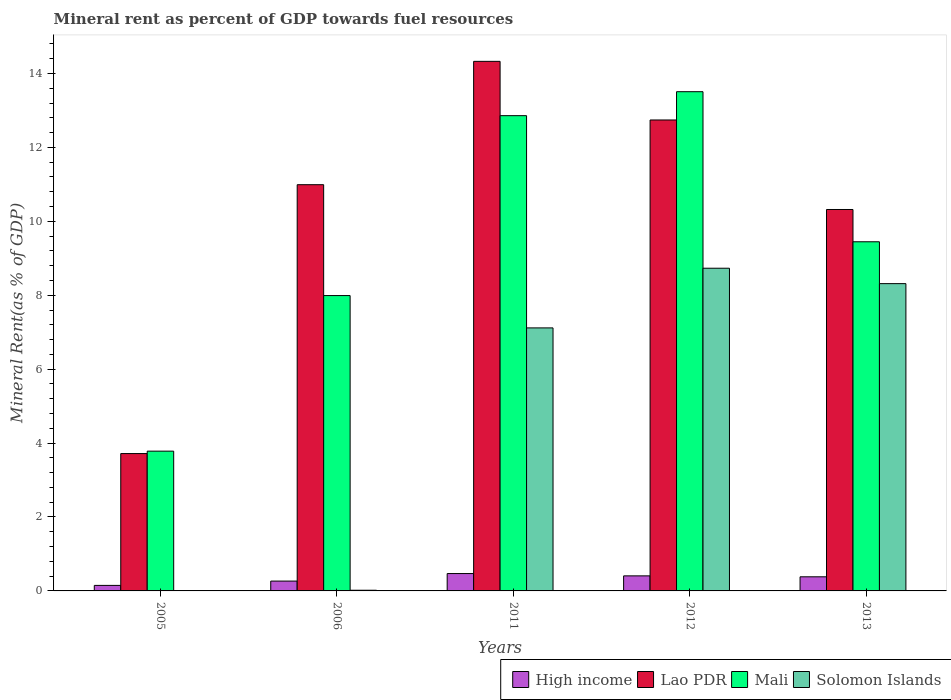Are the number of bars on each tick of the X-axis equal?
Provide a succinct answer. Yes. How many bars are there on the 4th tick from the left?
Keep it short and to the point. 4. How many bars are there on the 1st tick from the right?
Your response must be concise. 4. What is the label of the 4th group of bars from the left?
Offer a very short reply. 2012. In how many cases, is the number of bars for a given year not equal to the number of legend labels?
Provide a short and direct response. 0. What is the mineral rent in Lao PDR in 2013?
Make the answer very short. 10.32. Across all years, what is the maximum mineral rent in Lao PDR?
Your answer should be very brief. 14.33. Across all years, what is the minimum mineral rent in Solomon Islands?
Provide a short and direct response. 0.01. What is the total mineral rent in Mali in the graph?
Your answer should be very brief. 47.58. What is the difference between the mineral rent in High income in 2005 and that in 2013?
Offer a terse response. -0.23. What is the difference between the mineral rent in High income in 2011 and the mineral rent in Mali in 2013?
Keep it short and to the point. -8.98. What is the average mineral rent in Lao PDR per year?
Offer a very short reply. 10.42. In the year 2006, what is the difference between the mineral rent in Lao PDR and mineral rent in Mali?
Provide a short and direct response. 3. What is the ratio of the mineral rent in Mali in 2011 to that in 2012?
Provide a short and direct response. 0.95. What is the difference between the highest and the second highest mineral rent in Solomon Islands?
Your answer should be compact. 0.42. What is the difference between the highest and the lowest mineral rent in Mali?
Offer a terse response. 9.73. In how many years, is the mineral rent in Solomon Islands greater than the average mineral rent in Solomon Islands taken over all years?
Keep it short and to the point. 3. Is it the case that in every year, the sum of the mineral rent in Lao PDR and mineral rent in High income is greater than the sum of mineral rent in Solomon Islands and mineral rent in Mali?
Provide a short and direct response. No. What does the 2nd bar from the right in 2013 represents?
Ensure brevity in your answer.  Mali. Are all the bars in the graph horizontal?
Offer a terse response. No. How many years are there in the graph?
Provide a short and direct response. 5. What is the difference between two consecutive major ticks on the Y-axis?
Provide a succinct answer. 2. Are the values on the major ticks of Y-axis written in scientific E-notation?
Your answer should be very brief. No. Does the graph contain any zero values?
Provide a short and direct response. No. Where does the legend appear in the graph?
Provide a succinct answer. Bottom right. What is the title of the graph?
Offer a very short reply. Mineral rent as percent of GDP towards fuel resources. What is the label or title of the Y-axis?
Keep it short and to the point. Mineral Rent(as % of GDP). What is the Mineral Rent(as % of GDP) of High income in 2005?
Make the answer very short. 0.15. What is the Mineral Rent(as % of GDP) in Lao PDR in 2005?
Ensure brevity in your answer.  3.72. What is the Mineral Rent(as % of GDP) of Mali in 2005?
Offer a very short reply. 3.78. What is the Mineral Rent(as % of GDP) of Solomon Islands in 2005?
Give a very brief answer. 0.01. What is the Mineral Rent(as % of GDP) of High income in 2006?
Give a very brief answer. 0.27. What is the Mineral Rent(as % of GDP) of Lao PDR in 2006?
Your answer should be very brief. 10.99. What is the Mineral Rent(as % of GDP) of Mali in 2006?
Your answer should be compact. 7.99. What is the Mineral Rent(as % of GDP) of Solomon Islands in 2006?
Provide a short and direct response. 0.02. What is the Mineral Rent(as % of GDP) of High income in 2011?
Make the answer very short. 0.47. What is the Mineral Rent(as % of GDP) of Lao PDR in 2011?
Make the answer very short. 14.33. What is the Mineral Rent(as % of GDP) of Mali in 2011?
Provide a short and direct response. 12.86. What is the Mineral Rent(as % of GDP) in Solomon Islands in 2011?
Provide a succinct answer. 7.12. What is the Mineral Rent(as % of GDP) of High income in 2012?
Offer a very short reply. 0.41. What is the Mineral Rent(as % of GDP) in Lao PDR in 2012?
Keep it short and to the point. 12.74. What is the Mineral Rent(as % of GDP) of Mali in 2012?
Offer a very short reply. 13.51. What is the Mineral Rent(as % of GDP) of Solomon Islands in 2012?
Your answer should be compact. 8.73. What is the Mineral Rent(as % of GDP) of High income in 2013?
Offer a terse response. 0.38. What is the Mineral Rent(as % of GDP) of Lao PDR in 2013?
Keep it short and to the point. 10.32. What is the Mineral Rent(as % of GDP) in Mali in 2013?
Give a very brief answer. 9.45. What is the Mineral Rent(as % of GDP) in Solomon Islands in 2013?
Offer a terse response. 8.31. Across all years, what is the maximum Mineral Rent(as % of GDP) in High income?
Make the answer very short. 0.47. Across all years, what is the maximum Mineral Rent(as % of GDP) in Lao PDR?
Offer a very short reply. 14.33. Across all years, what is the maximum Mineral Rent(as % of GDP) in Mali?
Provide a short and direct response. 13.51. Across all years, what is the maximum Mineral Rent(as % of GDP) of Solomon Islands?
Provide a short and direct response. 8.73. Across all years, what is the minimum Mineral Rent(as % of GDP) of High income?
Your response must be concise. 0.15. Across all years, what is the minimum Mineral Rent(as % of GDP) of Lao PDR?
Your answer should be compact. 3.72. Across all years, what is the minimum Mineral Rent(as % of GDP) of Mali?
Keep it short and to the point. 3.78. Across all years, what is the minimum Mineral Rent(as % of GDP) in Solomon Islands?
Keep it short and to the point. 0.01. What is the total Mineral Rent(as % of GDP) in High income in the graph?
Your response must be concise. 1.67. What is the total Mineral Rent(as % of GDP) in Lao PDR in the graph?
Your answer should be compact. 52.1. What is the total Mineral Rent(as % of GDP) of Mali in the graph?
Give a very brief answer. 47.58. What is the total Mineral Rent(as % of GDP) of Solomon Islands in the graph?
Give a very brief answer. 24.19. What is the difference between the Mineral Rent(as % of GDP) of High income in 2005 and that in 2006?
Your answer should be compact. -0.12. What is the difference between the Mineral Rent(as % of GDP) of Lao PDR in 2005 and that in 2006?
Your answer should be compact. -7.27. What is the difference between the Mineral Rent(as % of GDP) of Mali in 2005 and that in 2006?
Provide a short and direct response. -4.21. What is the difference between the Mineral Rent(as % of GDP) of Solomon Islands in 2005 and that in 2006?
Your answer should be very brief. -0.01. What is the difference between the Mineral Rent(as % of GDP) of High income in 2005 and that in 2011?
Give a very brief answer. -0.32. What is the difference between the Mineral Rent(as % of GDP) of Lao PDR in 2005 and that in 2011?
Offer a terse response. -10.61. What is the difference between the Mineral Rent(as % of GDP) in Mali in 2005 and that in 2011?
Offer a very short reply. -9.08. What is the difference between the Mineral Rent(as % of GDP) in Solomon Islands in 2005 and that in 2011?
Your answer should be compact. -7.11. What is the difference between the Mineral Rent(as % of GDP) in High income in 2005 and that in 2012?
Make the answer very short. -0.26. What is the difference between the Mineral Rent(as % of GDP) in Lao PDR in 2005 and that in 2012?
Give a very brief answer. -9.03. What is the difference between the Mineral Rent(as % of GDP) of Mali in 2005 and that in 2012?
Your answer should be compact. -9.73. What is the difference between the Mineral Rent(as % of GDP) in Solomon Islands in 2005 and that in 2012?
Provide a succinct answer. -8.72. What is the difference between the Mineral Rent(as % of GDP) in High income in 2005 and that in 2013?
Provide a succinct answer. -0.23. What is the difference between the Mineral Rent(as % of GDP) of Lao PDR in 2005 and that in 2013?
Offer a terse response. -6.6. What is the difference between the Mineral Rent(as % of GDP) in Mali in 2005 and that in 2013?
Ensure brevity in your answer.  -5.66. What is the difference between the Mineral Rent(as % of GDP) in Solomon Islands in 2005 and that in 2013?
Your answer should be compact. -8.31. What is the difference between the Mineral Rent(as % of GDP) in High income in 2006 and that in 2011?
Your response must be concise. -0.2. What is the difference between the Mineral Rent(as % of GDP) of Lao PDR in 2006 and that in 2011?
Your answer should be compact. -3.34. What is the difference between the Mineral Rent(as % of GDP) in Mali in 2006 and that in 2011?
Keep it short and to the point. -4.87. What is the difference between the Mineral Rent(as % of GDP) of Solomon Islands in 2006 and that in 2011?
Keep it short and to the point. -7.1. What is the difference between the Mineral Rent(as % of GDP) in High income in 2006 and that in 2012?
Your response must be concise. -0.14. What is the difference between the Mineral Rent(as % of GDP) of Lao PDR in 2006 and that in 2012?
Your answer should be compact. -1.75. What is the difference between the Mineral Rent(as % of GDP) in Mali in 2006 and that in 2012?
Ensure brevity in your answer.  -5.52. What is the difference between the Mineral Rent(as % of GDP) in Solomon Islands in 2006 and that in 2012?
Offer a terse response. -8.71. What is the difference between the Mineral Rent(as % of GDP) of High income in 2006 and that in 2013?
Keep it short and to the point. -0.12. What is the difference between the Mineral Rent(as % of GDP) of Lao PDR in 2006 and that in 2013?
Keep it short and to the point. 0.67. What is the difference between the Mineral Rent(as % of GDP) of Mali in 2006 and that in 2013?
Your answer should be compact. -1.46. What is the difference between the Mineral Rent(as % of GDP) in Solomon Islands in 2006 and that in 2013?
Provide a succinct answer. -8.3. What is the difference between the Mineral Rent(as % of GDP) of High income in 2011 and that in 2012?
Keep it short and to the point. 0.06. What is the difference between the Mineral Rent(as % of GDP) in Lao PDR in 2011 and that in 2012?
Keep it short and to the point. 1.59. What is the difference between the Mineral Rent(as % of GDP) of Mali in 2011 and that in 2012?
Make the answer very short. -0.65. What is the difference between the Mineral Rent(as % of GDP) in Solomon Islands in 2011 and that in 2012?
Keep it short and to the point. -1.61. What is the difference between the Mineral Rent(as % of GDP) of High income in 2011 and that in 2013?
Give a very brief answer. 0.09. What is the difference between the Mineral Rent(as % of GDP) in Lao PDR in 2011 and that in 2013?
Offer a very short reply. 4.01. What is the difference between the Mineral Rent(as % of GDP) of Mali in 2011 and that in 2013?
Ensure brevity in your answer.  3.41. What is the difference between the Mineral Rent(as % of GDP) in Solomon Islands in 2011 and that in 2013?
Your answer should be compact. -1.2. What is the difference between the Mineral Rent(as % of GDP) in High income in 2012 and that in 2013?
Provide a short and direct response. 0.03. What is the difference between the Mineral Rent(as % of GDP) of Lao PDR in 2012 and that in 2013?
Keep it short and to the point. 2.42. What is the difference between the Mineral Rent(as % of GDP) of Mali in 2012 and that in 2013?
Provide a short and direct response. 4.06. What is the difference between the Mineral Rent(as % of GDP) in Solomon Islands in 2012 and that in 2013?
Provide a short and direct response. 0.42. What is the difference between the Mineral Rent(as % of GDP) in High income in 2005 and the Mineral Rent(as % of GDP) in Lao PDR in 2006?
Give a very brief answer. -10.84. What is the difference between the Mineral Rent(as % of GDP) in High income in 2005 and the Mineral Rent(as % of GDP) in Mali in 2006?
Provide a short and direct response. -7.84. What is the difference between the Mineral Rent(as % of GDP) of High income in 2005 and the Mineral Rent(as % of GDP) of Solomon Islands in 2006?
Your response must be concise. 0.13. What is the difference between the Mineral Rent(as % of GDP) in Lao PDR in 2005 and the Mineral Rent(as % of GDP) in Mali in 2006?
Make the answer very short. -4.27. What is the difference between the Mineral Rent(as % of GDP) of Lao PDR in 2005 and the Mineral Rent(as % of GDP) of Solomon Islands in 2006?
Your answer should be compact. 3.7. What is the difference between the Mineral Rent(as % of GDP) of Mali in 2005 and the Mineral Rent(as % of GDP) of Solomon Islands in 2006?
Offer a very short reply. 3.76. What is the difference between the Mineral Rent(as % of GDP) in High income in 2005 and the Mineral Rent(as % of GDP) in Lao PDR in 2011?
Your answer should be very brief. -14.18. What is the difference between the Mineral Rent(as % of GDP) in High income in 2005 and the Mineral Rent(as % of GDP) in Mali in 2011?
Your answer should be compact. -12.71. What is the difference between the Mineral Rent(as % of GDP) in High income in 2005 and the Mineral Rent(as % of GDP) in Solomon Islands in 2011?
Offer a very short reply. -6.97. What is the difference between the Mineral Rent(as % of GDP) of Lao PDR in 2005 and the Mineral Rent(as % of GDP) of Mali in 2011?
Make the answer very short. -9.14. What is the difference between the Mineral Rent(as % of GDP) in Lao PDR in 2005 and the Mineral Rent(as % of GDP) in Solomon Islands in 2011?
Provide a succinct answer. -3.4. What is the difference between the Mineral Rent(as % of GDP) of Mali in 2005 and the Mineral Rent(as % of GDP) of Solomon Islands in 2011?
Your answer should be compact. -3.33. What is the difference between the Mineral Rent(as % of GDP) in High income in 2005 and the Mineral Rent(as % of GDP) in Lao PDR in 2012?
Offer a very short reply. -12.59. What is the difference between the Mineral Rent(as % of GDP) of High income in 2005 and the Mineral Rent(as % of GDP) of Mali in 2012?
Your answer should be compact. -13.36. What is the difference between the Mineral Rent(as % of GDP) of High income in 2005 and the Mineral Rent(as % of GDP) of Solomon Islands in 2012?
Make the answer very short. -8.58. What is the difference between the Mineral Rent(as % of GDP) in Lao PDR in 2005 and the Mineral Rent(as % of GDP) in Mali in 2012?
Offer a terse response. -9.79. What is the difference between the Mineral Rent(as % of GDP) in Lao PDR in 2005 and the Mineral Rent(as % of GDP) in Solomon Islands in 2012?
Keep it short and to the point. -5.01. What is the difference between the Mineral Rent(as % of GDP) of Mali in 2005 and the Mineral Rent(as % of GDP) of Solomon Islands in 2012?
Ensure brevity in your answer.  -4.95. What is the difference between the Mineral Rent(as % of GDP) of High income in 2005 and the Mineral Rent(as % of GDP) of Lao PDR in 2013?
Your answer should be compact. -10.17. What is the difference between the Mineral Rent(as % of GDP) in High income in 2005 and the Mineral Rent(as % of GDP) in Mali in 2013?
Make the answer very short. -9.3. What is the difference between the Mineral Rent(as % of GDP) in High income in 2005 and the Mineral Rent(as % of GDP) in Solomon Islands in 2013?
Your answer should be compact. -8.16. What is the difference between the Mineral Rent(as % of GDP) in Lao PDR in 2005 and the Mineral Rent(as % of GDP) in Mali in 2013?
Provide a succinct answer. -5.73. What is the difference between the Mineral Rent(as % of GDP) of Lao PDR in 2005 and the Mineral Rent(as % of GDP) of Solomon Islands in 2013?
Provide a short and direct response. -4.6. What is the difference between the Mineral Rent(as % of GDP) of Mali in 2005 and the Mineral Rent(as % of GDP) of Solomon Islands in 2013?
Your answer should be compact. -4.53. What is the difference between the Mineral Rent(as % of GDP) of High income in 2006 and the Mineral Rent(as % of GDP) of Lao PDR in 2011?
Keep it short and to the point. -14.06. What is the difference between the Mineral Rent(as % of GDP) of High income in 2006 and the Mineral Rent(as % of GDP) of Mali in 2011?
Your answer should be compact. -12.59. What is the difference between the Mineral Rent(as % of GDP) of High income in 2006 and the Mineral Rent(as % of GDP) of Solomon Islands in 2011?
Ensure brevity in your answer.  -6.85. What is the difference between the Mineral Rent(as % of GDP) in Lao PDR in 2006 and the Mineral Rent(as % of GDP) in Mali in 2011?
Keep it short and to the point. -1.87. What is the difference between the Mineral Rent(as % of GDP) in Lao PDR in 2006 and the Mineral Rent(as % of GDP) in Solomon Islands in 2011?
Ensure brevity in your answer.  3.87. What is the difference between the Mineral Rent(as % of GDP) in Mali in 2006 and the Mineral Rent(as % of GDP) in Solomon Islands in 2011?
Make the answer very short. 0.87. What is the difference between the Mineral Rent(as % of GDP) in High income in 2006 and the Mineral Rent(as % of GDP) in Lao PDR in 2012?
Give a very brief answer. -12.48. What is the difference between the Mineral Rent(as % of GDP) in High income in 2006 and the Mineral Rent(as % of GDP) in Mali in 2012?
Offer a very short reply. -13.24. What is the difference between the Mineral Rent(as % of GDP) of High income in 2006 and the Mineral Rent(as % of GDP) of Solomon Islands in 2012?
Offer a very short reply. -8.46. What is the difference between the Mineral Rent(as % of GDP) in Lao PDR in 2006 and the Mineral Rent(as % of GDP) in Mali in 2012?
Make the answer very short. -2.52. What is the difference between the Mineral Rent(as % of GDP) in Lao PDR in 2006 and the Mineral Rent(as % of GDP) in Solomon Islands in 2012?
Your answer should be very brief. 2.26. What is the difference between the Mineral Rent(as % of GDP) of Mali in 2006 and the Mineral Rent(as % of GDP) of Solomon Islands in 2012?
Offer a terse response. -0.74. What is the difference between the Mineral Rent(as % of GDP) in High income in 2006 and the Mineral Rent(as % of GDP) in Lao PDR in 2013?
Provide a short and direct response. -10.05. What is the difference between the Mineral Rent(as % of GDP) in High income in 2006 and the Mineral Rent(as % of GDP) in Mali in 2013?
Your answer should be very brief. -9.18. What is the difference between the Mineral Rent(as % of GDP) in High income in 2006 and the Mineral Rent(as % of GDP) in Solomon Islands in 2013?
Provide a succinct answer. -8.05. What is the difference between the Mineral Rent(as % of GDP) in Lao PDR in 2006 and the Mineral Rent(as % of GDP) in Mali in 2013?
Provide a succinct answer. 1.54. What is the difference between the Mineral Rent(as % of GDP) in Lao PDR in 2006 and the Mineral Rent(as % of GDP) in Solomon Islands in 2013?
Give a very brief answer. 2.68. What is the difference between the Mineral Rent(as % of GDP) in Mali in 2006 and the Mineral Rent(as % of GDP) in Solomon Islands in 2013?
Your answer should be very brief. -0.32. What is the difference between the Mineral Rent(as % of GDP) of High income in 2011 and the Mineral Rent(as % of GDP) of Lao PDR in 2012?
Offer a terse response. -12.27. What is the difference between the Mineral Rent(as % of GDP) in High income in 2011 and the Mineral Rent(as % of GDP) in Mali in 2012?
Ensure brevity in your answer.  -13.04. What is the difference between the Mineral Rent(as % of GDP) in High income in 2011 and the Mineral Rent(as % of GDP) in Solomon Islands in 2012?
Provide a succinct answer. -8.26. What is the difference between the Mineral Rent(as % of GDP) of Lao PDR in 2011 and the Mineral Rent(as % of GDP) of Mali in 2012?
Your answer should be compact. 0.82. What is the difference between the Mineral Rent(as % of GDP) of Lao PDR in 2011 and the Mineral Rent(as % of GDP) of Solomon Islands in 2012?
Make the answer very short. 5.6. What is the difference between the Mineral Rent(as % of GDP) of Mali in 2011 and the Mineral Rent(as % of GDP) of Solomon Islands in 2012?
Make the answer very short. 4.13. What is the difference between the Mineral Rent(as % of GDP) of High income in 2011 and the Mineral Rent(as % of GDP) of Lao PDR in 2013?
Give a very brief answer. -9.85. What is the difference between the Mineral Rent(as % of GDP) of High income in 2011 and the Mineral Rent(as % of GDP) of Mali in 2013?
Provide a short and direct response. -8.98. What is the difference between the Mineral Rent(as % of GDP) in High income in 2011 and the Mineral Rent(as % of GDP) in Solomon Islands in 2013?
Provide a succinct answer. -7.84. What is the difference between the Mineral Rent(as % of GDP) in Lao PDR in 2011 and the Mineral Rent(as % of GDP) in Mali in 2013?
Your answer should be very brief. 4.88. What is the difference between the Mineral Rent(as % of GDP) of Lao PDR in 2011 and the Mineral Rent(as % of GDP) of Solomon Islands in 2013?
Ensure brevity in your answer.  6.01. What is the difference between the Mineral Rent(as % of GDP) in Mali in 2011 and the Mineral Rent(as % of GDP) in Solomon Islands in 2013?
Offer a very short reply. 4.54. What is the difference between the Mineral Rent(as % of GDP) in High income in 2012 and the Mineral Rent(as % of GDP) in Lao PDR in 2013?
Your response must be concise. -9.91. What is the difference between the Mineral Rent(as % of GDP) in High income in 2012 and the Mineral Rent(as % of GDP) in Mali in 2013?
Provide a short and direct response. -9.04. What is the difference between the Mineral Rent(as % of GDP) in High income in 2012 and the Mineral Rent(as % of GDP) in Solomon Islands in 2013?
Your response must be concise. -7.91. What is the difference between the Mineral Rent(as % of GDP) in Lao PDR in 2012 and the Mineral Rent(as % of GDP) in Mali in 2013?
Your response must be concise. 3.3. What is the difference between the Mineral Rent(as % of GDP) of Lao PDR in 2012 and the Mineral Rent(as % of GDP) of Solomon Islands in 2013?
Give a very brief answer. 4.43. What is the difference between the Mineral Rent(as % of GDP) of Mali in 2012 and the Mineral Rent(as % of GDP) of Solomon Islands in 2013?
Your answer should be compact. 5.19. What is the average Mineral Rent(as % of GDP) in High income per year?
Keep it short and to the point. 0.33. What is the average Mineral Rent(as % of GDP) in Lao PDR per year?
Make the answer very short. 10.42. What is the average Mineral Rent(as % of GDP) of Mali per year?
Keep it short and to the point. 9.52. What is the average Mineral Rent(as % of GDP) in Solomon Islands per year?
Ensure brevity in your answer.  4.84. In the year 2005, what is the difference between the Mineral Rent(as % of GDP) in High income and Mineral Rent(as % of GDP) in Lao PDR?
Provide a succinct answer. -3.57. In the year 2005, what is the difference between the Mineral Rent(as % of GDP) in High income and Mineral Rent(as % of GDP) in Mali?
Ensure brevity in your answer.  -3.63. In the year 2005, what is the difference between the Mineral Rent(as % of GDP) of High income and Mineral Rent(as % of GDP) of Solomon Islands?
Offer a very short reply. 0.14. In the year 2005, what is the difference between the Mineral Rent(as % of GDP) in Lao PDR and Mineral Rent(as % of GDP) in Mali?
Offer a terse response. -0.07. In the year 2005, what is the difference between the Mineral Rent(as % of GDP) of Lao PDR and Mineral Rent(as % of GDP) of Solomon Islands?
Offer a very short reply. 3.71. In the year 2005, what is the difference between the Mineral Rent(as % of GDP) in Mali and Mineral Rent(as % of GDP) in Solomon Islands?
Make the answer very short. 3.77. In the year 2006, what is the difference between the Mineral Rent(as % of GDP) in High income and Mineral Rent(as % of GDP) in Lao PDR?
Provide a succinct answer. -10.72. In the year 2006, what is the difference between the Mineral Rent(as % of GDP) of High income and Mineral Rent(as % of GDP) of Mali?
Offer a terse response. -7.72. In the year 2006, what is the difference between the Mineral Rent(as % of GDP) in High income and Mineral Rent(as % of GDP) in Solomon Islands?
Provide a succinct answer. 0.25. In the year 2006, what is the difference between the Mineral Rent(as % of GDP) of Lao PDR and Mineral Rent(as % of GDP) of Mali?
Offer a terse response. 3. In the year 2006, what is the difference between the Mineral Rent(as % of GDP) of Lao PDR and Mineral Rent(as % of GDP) of Solomon Islands?
Offer a very short reply. 10.97. In the year 2006, what is the difference between the Mineral Rent(as % of GDP) in Mali and Mineral Rent(as % of GDP) in Solomon Islands?
Make the answer very short. 7.97. In the year 2011, what is the difference between the Mineral Rent(as % of GDP) in High income and Mineral Rent(as % of GDP) in Lao PDR?
Keep it short and to the point. -13.86. In the year 2011, what is the difference between the Mineral Rent(as % of GDP) of High income and Mineral Rent(as % of GDP) of Mali?
Ensure brevity in your answer.  -12.39. In the year 2011, what is the difference between the Mineral Rent(as % of GDP) of High income and Mineral Rent(as % of GDP) of Solomon Islands?
Your answer should be very brief. -6.65. In the year 2011, what is the difference between the Mineral Rent(as % of GDP) of Lao PDR and Mineral Rent(as % of GDP) of Mali?
Your answer should be compact. 1.47. In the year 2011, what is the difference between the Mineral Rent(as % of GDP) of Lao PDR and Mineral Rent(as % of GDP) of Solomon Islands?
Offer a terse response. 7.21. In the year 2011, what is the difference between the Mineral Rent(as % of GDP) of Mali and Mineral Rent(as % of GDP) of Solomon Islands?
Make the answer very short. 5.74. In the year 2012, what is the difference between the Mineral Rent(as % of GDP) of High income and Mineral Rent(as % of GDP) of Lao PDR?
Give a very brief answer. -12.33. In the year 2012, what is the difference between the Mineral Rent(as % of GDP) of High income and Mineral Rent(as % of GDP) of Mali?
Give a very brief answer. -13.1. In the year 2012, what is the difference between the Mineral Rent(as % of GDP) in High income and Mineral Rent(as % of GDP) in Solomon Islands?
Offer a very short reply. -8.32. In the year 2012, what is the difference between the Mineral Rent(as % of GDP) in Lao PDR and Mineral Rent(as % of GDP) in Mali?
Offer a terse response. -0.77. In the year 2012, what is the difference between the Mineral Rent(as % of GDP) of Lao PDR and Mineral Rent(as % of GDP) of Solomon Islands?
Offer a terse response. 4.01. In the year 2012, what is the difference between the Mineral Rent(as % of GDP) in Mali and Mineral Rent(as % of GDP) in Solomon Islands?
Give a very brief answer. 4.78. In the year 2013, what is the difference between the Mineral Rent(as % of GDP) of High income and Mineral Rent(as % of GDP) of Lao PDR?
Your response must be concise. -9.94. In the year 2013, what is the difference between the Mineral Rent(as % of GDP) in High income and Mineral Rent(as % of GDP) in Mali?
Your answer should be very brief. -9.06. In the year 2013, what is the difference between the Mineral Rent(as % of GDP) of High income and Mineral Rent(as % of GDP) of Solomon Islands?
Provide a succinct answer. -7.93. In the year 2013, what is the difference between the Mineral Rent(as % of GDP) in Lao PDR and Mineral Rent(as % of GDP) in Mali?
Make the answer very short. 0.87. In the year 2013, what is the difference between the Mineral Rent(as % of GDP) in Lao PDR and Mineral Rent(as % of GDP) in Solomon Islands?
Make the answer very short. 2.01. In the year 2013, what is the difference between the Mineral Rent(as % of GDP) in Mali and Mineral Rent(as % of GDP) in Solomon Islands?
Keep it short and to the point. 1.13. What is the ratio of the Mineral Rent(as % of GDP) of High income in 2005 to that in 2006?
Offer a very short reply. 0.56. What is the ratio of the Mineral Rent(as % of GDP) in Lao PDR in 2005 to that in 2006?
Your answer should be compact. 0.34. What is the ratio of the Mineral Rent(as % of GDP) in Mali in 2005 to that in 2006?
Make the answer very short. 0.47. What is the ratio of the Mineral Rent(as % of GDP) in Solomon Islands in 2005 to that in 2006?
Your response must be concise. 0.47. What is the ratio of the Mineral Rent(as % of GDP) in High income in 2005 to that in 2011?
Offer a very short reply. 0.32. What is the ratio of the Mineral Rent(as % of GDP) of Lao PDR in 2005 to that in 2011?
Provide a short and direct response. 0.26. What is the ratio of the Mineral Rent(as % of GDP) in Mali in 2005 to that in 2011?
Give a very brief answer. 0.29. What is the ratio of the Mineral Rent(as % of GDP) of Solomon Islands in 2005 to that in 2011?
Provide a succinct answer. 0. What is the ratio of the Mineral Rent(as % of GDP) in High income in 2005 to that in 2012?
Provide a succinct answer. 0.37. What is the ratio of the Mineral Rent(as % of GDP) in Lao PDR in 2005 to that in 2012?
Provide a short and direct response. 0.29. What is the ratio of the Mineral Rent(as % of GDP) of Mali in 2005 to that in 2012?
Keep it short and to the point. 0.28. What is the ratio of the Mineral Rent(as % of GDP) of Solomon Islands in 2005 to that in 2012?
Your response must be concise. 0. What is the ratio of the Mineral Rent(as % of GDP) of High income in 2005 to that in 2013?
Your answer should be very brief. 0.39. What is the ratio of the Mineral Rent(as % of GDP) of Lao PDR in 2005 to that in 2013?
Provide a succinct answer. 0.36. What is the ratio of the Mineral Rent(as % of GDP) in Mali in 2005 to that in 2013?
Ensure brevity in your answer.  0.4. What is the ratio of the Mineral Rent(as % of GDP) in Solomon Islands in 2005 to that in 2013?
Ensure brevity in your answer.  0. What is the ratio of the Mineral Rent(as % of GDP) in High income in 2006 to that in 2011?
Ensure brevity in your answer.  0.57. What is the ratio of the Mineral Rent(as % of GDP) of Lao PDR in 2006 to that in 2011?
Offer a very short reply. 0.77. What is the ratio of the Mineral Rent(as % of GDP) in Mali in 2006 to that in 2011?
Provide a succinct answer. 0.62. What is the ratio of the Mineral Rent(as % of GDP) in Solomon Islands in 2006 to that in 2011?
Ensure brevity in your answer.  0. What is the ratio of the Mineral Rent(as % of GDP) of High income in 2006 to that in 2012?
Your answer should be compact. 0.65. What is the ratio of the Mineral Rent(as % of GDP) in Lao PDR in 2006 to that in 2012?
Make the answer very short. 0.86. What is the ratio of the Mineral Rent(as % of GDP) in Mali in 2006 to that in 2012?
Ensure brevity in your answer.  0.59. What is the ratio of the Mineral Rent(as % of GDP) in Solomon Islands in 2006 to that in 2012?
Keep it short and to the point. 0. What is the ratio of the Mineral Rent(as % of GDP) in High income in 2006 to that in 2013?
Your response must be concise. 0.7. What is the ratio of the Mineral Rent(as % of GDP) in Lao PDR in 2006 to that in 2013?
Make the answer very short. 1.06. What is the ratio of the Mineral Rent(as % of GDP) in Mali in 2006 to that in 2013?
Your answer should be very brief. 0.85. What is the ratio of the Mineral Rent(as % of GDP) in Solomon Islands in 2006 to that in 2013?
Give a very brief answer. 0. What is the ratio of the Mineral Rent(as % of GDP) in High income in 2011 to that in 2012?
Keep it short and to the point. 1.15. What is the ratio of the Mineral Rent(as % of GDP) in Lao PDR in 2011 to that in 2012?
Provide a short and direct response. 1.12. What is the ratio of the Mineral Rent(as % of GDP) of Mali in 2011 to that in 2012?
Your answer should be compact. 0.95. What is the ratio of the Mineral Rent(as % of GDP) of Solomon Islands in 2011 to that in 2012?
Provide a succinct answer. 0.82. What is the ratio of the Mineral Rent(as % of GDP) of High income in 2011 to that in 2013?
Make the answer very short. 1.23. What is the ratio of the Mineral Rent(as % of GDP) in Lao PDR in 2011 to that in 2013?
Your response must be concise. 1.39. What is the ratio of the Mineral Rent(as % of GDP) in Mali in 2011 to that in 2013?
Your response must be concise. 1.36. What is the ratio of the Mineral Rent(as % of GDP) of Solomon Islands in 2011 to that in 2013?
Offer a very short reply. 0.86. What is the ratio of the Mineral Rent(as % of GDP) of High income in 2012 to that in 2013?
Offer a terse response. 1.07. What is the ratio of the Mineral Rent(as % of GDP) of Lao PDR in 2012 to that in 2013?
Provide a succinct answer. 1.23. What is the ratio of the Mineral Rent(as % of GDP) in Mali in 2012 to that in 2013?
Ensure brevity in your answer.  1.43. What is the ratio of the Mineral Rent(as % of GDP) of Solomon Islands in 2012 to that in 2013?
Offer a very short reply. 1.05. What is the difference between the highest and the second highest Mineral Rent(as % of GDP) in High income?
Ensure brevity in your answer.  0.06. What is the difference between the highest and the second highest Mineral Rent(as % of GDP) in Lao PDR?
Provide a short and direct response. 1.59. What is the difference between the highest and the second highest Mineral Rent(as % of GDP) in Mali?
Provide a succinct answer. 0.65. What is the difference between the highest and the second highest Mineral Rent(as % of GDP) in Solomon Islands?
Provide a short and direct response. 0.42. What is the difference between the highest and the lowest Mineral Rent(as % of GDP) of High income?
Offer a terse response. 0.32. What is the difference between the highest and the lowest Mineral Rent(as % of GDP) in Lao PDR?
Your response must be concise. 10.61. What is the difference between the highest and the lowest Mineral Rent(as % of GDP) of Mali?
Keep it short and to the point. 9.73. What is the difference between the highest and the lowest Mineral Rent(as % of GDP) of Solomon Islands?
Provide a succinct answer. 8.72. 